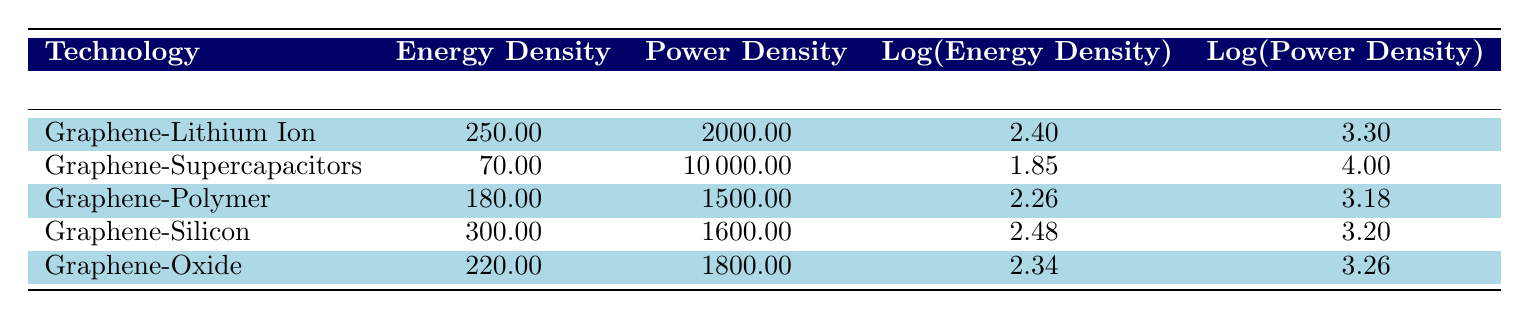What is the energy density of Graphene-Supercapacitors? The energy density of Graphene-Supercapacitors is provided directly in the table, which states it as 70.00 mWh/g.
Answer: 70.00 mWh/g Which technology has the highest power density? By comparing the power densities listed in the table, Graphene-Supercapacitors is noted to have the highest power density of 10000.00 W/kg.
Answer: Graphene-Supercapacitors What is the energy density range in this table? The highest energy density is 300.00 mWh/g for Graphene-Silicon and the lowest is 70.00 mWh/g for Graphene-Supercapacitors. Therefore, the range can be calculated as 300.00 - 70.00 = 230.00 mWh/g.
Answer: 230.00 mWh/g Is the power density of Graphene-Lithium Ion Batteries greater than that of Graphene-Polymer Batteries? The table shows that Graphene-Lithium Ion Batteries have a power density of 2000.00 W/kg, while Graphene-Polymer Batteries have a power density of 1500.00 W/kg. Since 2000.00 is greater than 1500.00, the statement is true.
Answer: Yes What is the average energy density of all the graphene battery technologies listed? To find the average, add all energy densities: (250 + 70 + 180 + 300 + 220) = 1020. Then divide by the number of technologies (5): 1020 / 5 = 204.00 mWh/g.
Answer: 204.00 mWh/g Which technology has a power density below 2000 W/kg? From the table, the only technology with a power density below 2000.00 W/kg is Graphene-Polymer Batteries at 1500.00 W/kg.
Answer: Graphene-Polymer Batteries What is the difference between the energy density of Graphene-Oxide and Graphene-Silicon Batteries? Graphene-Oxide has an energy density of 220.00 mWh/g and Graphene-Silicon has 300.00 mWh/g. The difference can be calculated as 300.00 - 220.00 = 80.00 mWh/g.
Answer: 80.00 mWh/g Do Graphene-Lithium Ion Batteries have a higher energy density compared to Graphene-Oxide Batteries? Graphene-Lithium Ion Batteries have an energy density of 250.00 mWh/g while Graphene-Oxide Batteries have 220.00 mWh/g, confirming that Graphene-Lithium Ion Batteries have the higher energy density.
Answer: Yes 